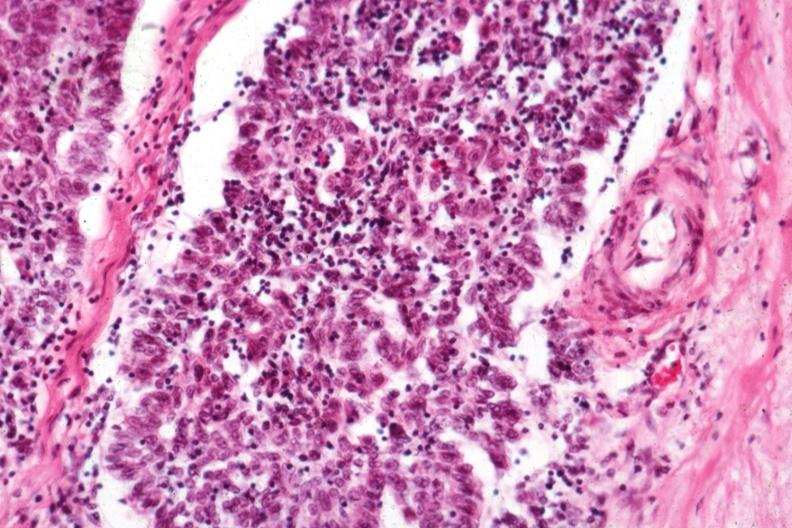what is present?
Answer the question using a single word or phrase. Thymoma 